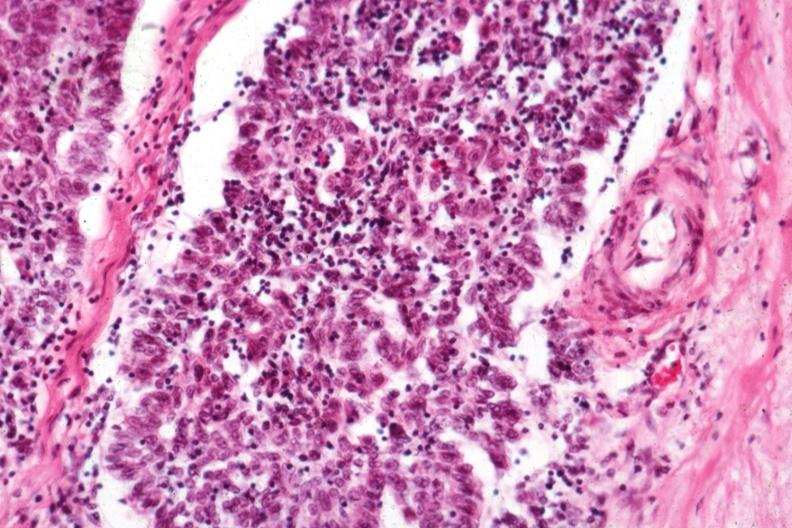what is present?
Answer the question using a single word or phrase. Thymoma 